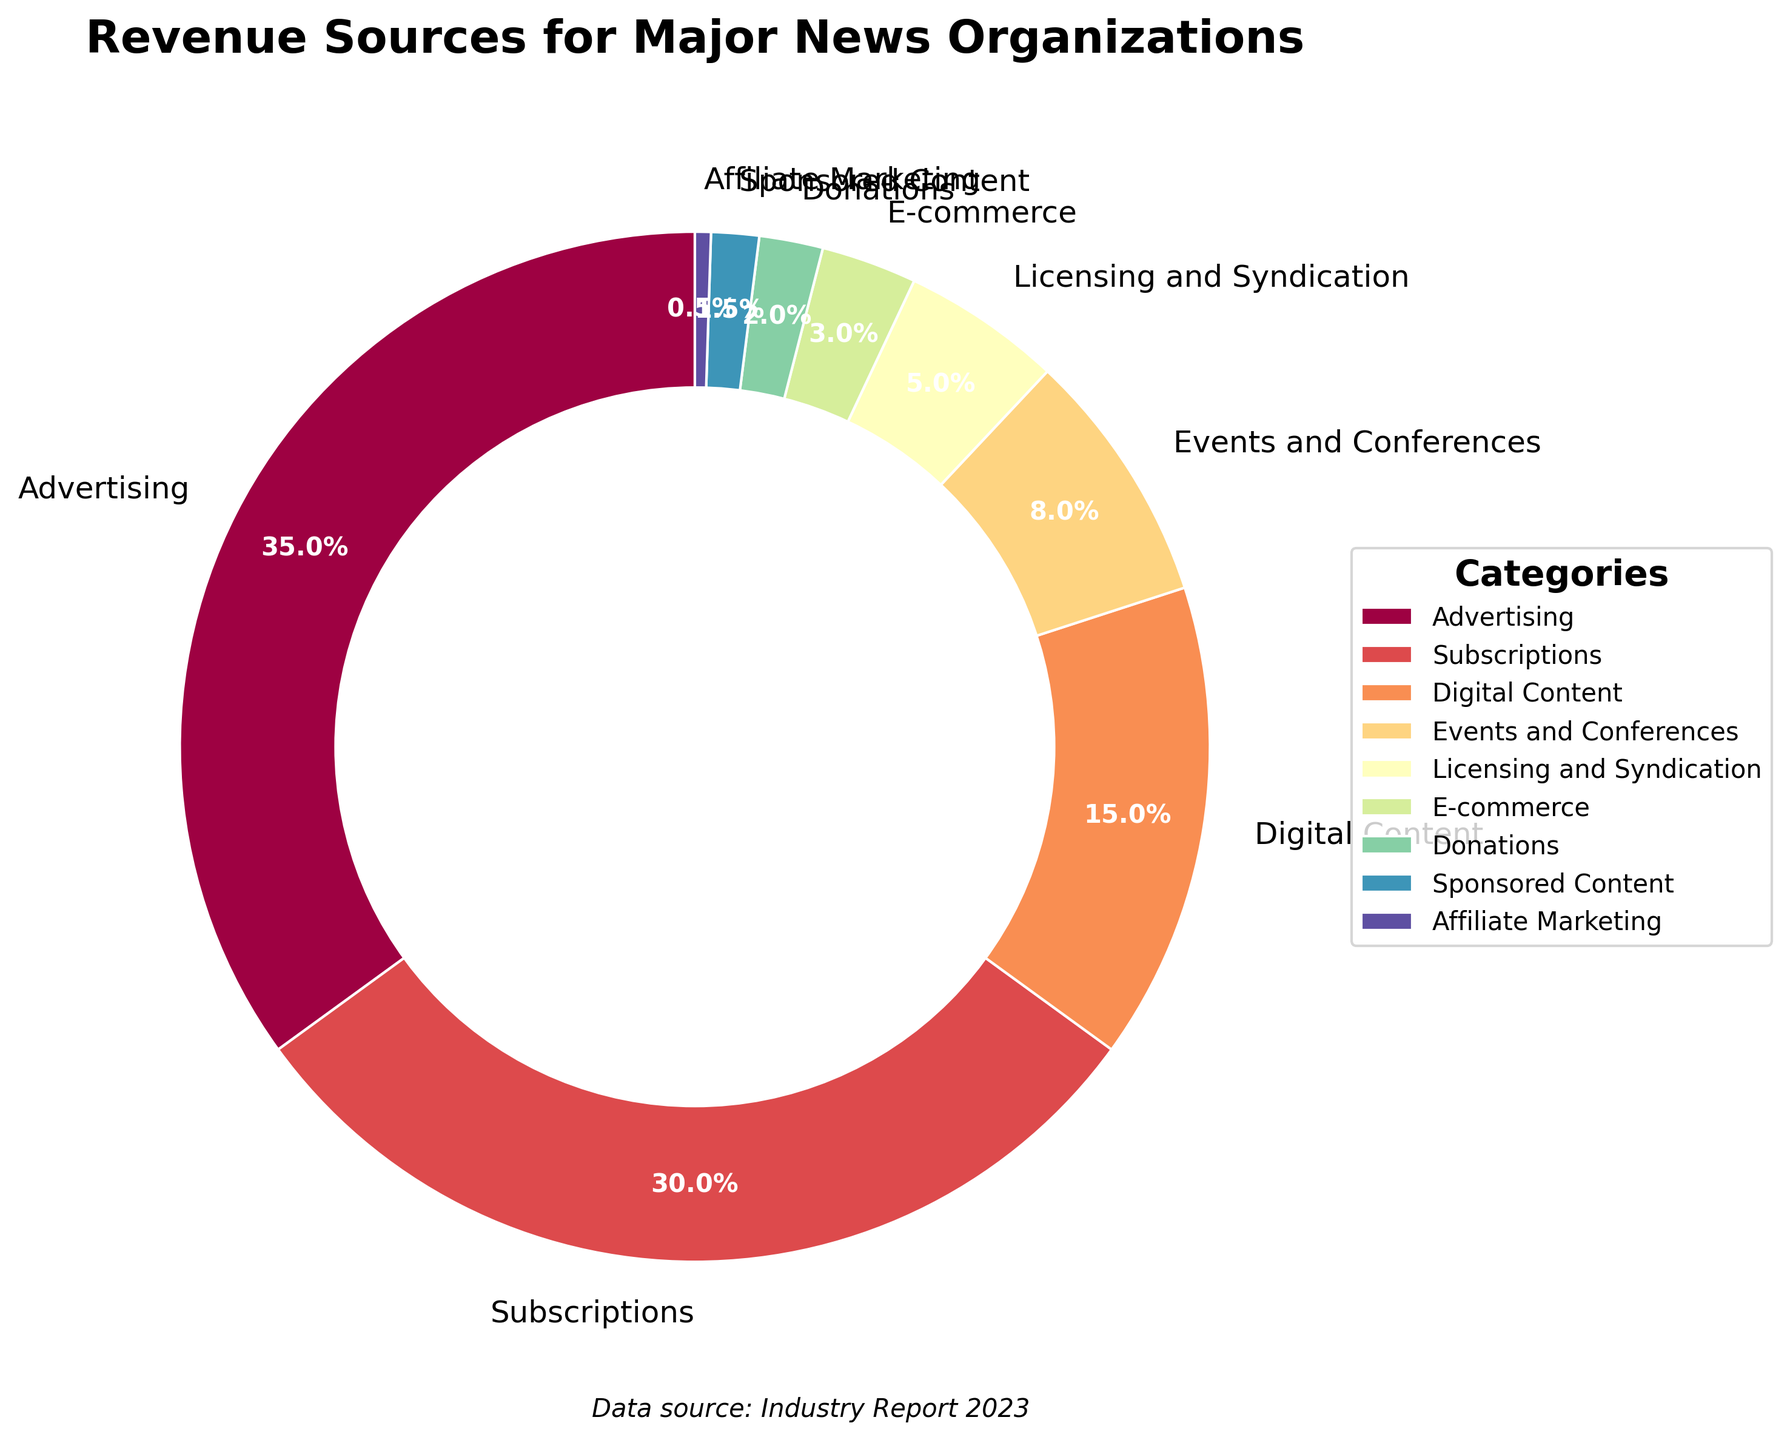What is the largest revenue source for major news organizations? The pie chart shows that Advertising has the largest percentage among all categories.
Answer: Advertising What percentage of revenue comes from Subscriptions compared to Advertising? Subscriptions contribute 30% of the revenue, whereas Advertising contributes 35%. To find the percentage comparison, (30/35) * 100% ≈ 85.7%.
Answer: Approximately 85.7% What is the combined revenue percentage from Events and Conferences, Licensing and Syndication, E-commerce, Donations, Sponsored Content, and Affiliate Marketing? Adding the percentages of these categories: 8% (Events and Conferences) + 5% (Licensing and Syndication) + 3% (E-commerce) + 2% (Donations) + 1.5% (Sponsored Content) + 0.5% (Affiliate Marketing) = 20%.
Answer: 20% Which revenue source contributes the least, and what is its percentage? The pie chart indicates that Affiliate Marketing contributes the least at 0.5%.
Answer: Affiliate Marketing at 0.5% How does the revenue from Digital Content compare to the revenue from Licensing and Syndication? Digital Content has 15% and Licensing and Syndication has 5%. Digital Content's percentage is 3 times greater than Licensing and Syndication's.
Answer: Digital Content is 3 times greater What is the percentage difference between the revenue from Donations and E-commerce? E-commerce contributes 3%, and Donations contribute 2%. The difference is 3% - 2% = 1%.
Answer: 1% Which category has the closest contribution to Subscriptions, and what is its exact percentage? Digital Content, with 15%, is the category closest to Subscriptions, which has 30%.
Answer: Digital Content at 15% How much greater is the combined revenue from Advertising and Subscriptions compared to the combined revenue from all other categories? The combined percentage of Advertising and Subscriptions is 35% + 30% = 65%. The combined percentage of the other categories is 100% - 65% = 35%. Therefore, Advertising and Subscriptions together are 65% - 35% = 30% greater than the others.
Answer: 30% greater When combined, do Advertising and Subscriptions account for more than half of total revenue? Yes, adding Advertising's 35% and Subscriptions' 30%, the total is 65%, which is more than half of 100%.
Answer: Yes 